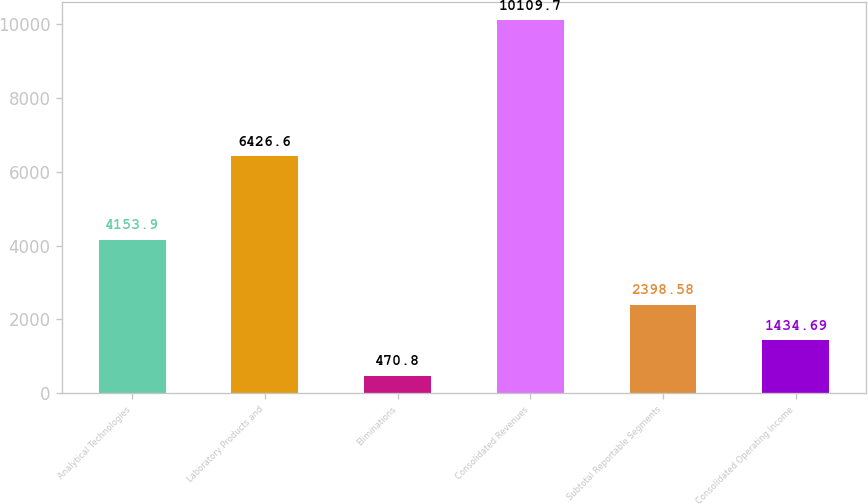<chart> <loc_0><loc_0><loc_500><loc_500><bar_chart><fcel>Analytical Technologies<fcel>Laboratory Products and<fcel>Eliminations<fcel>Consolidated Revenues<fcel>Subtotal Reportable Segments<fcel>Consolidated Operating Income<nl><fcel>4153.9<fcel>6426.6<fcel>470.8<fcel>10109.7<fcel>2398.58<fcel>1434.69<nl></chart> 